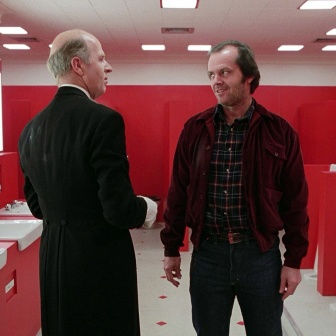Create a playful interaction based on this image. Human:  What do you think these men are plotting with such serious expressions?

GPT: Maybe they’re planning the ultimate office prank! The man in the black suit could be the mastermind, showing the man in the red jacket a detailed map of their colleague's cubicle. They’re discussing how to fill it with hundreds of balloons without getting caught. Their serious expressions are because they know this is a high-stakes operation and they cannot afford to leave any evidence behind. What happens next? Do they pull it off without a hitch or does something hilariously unexpected derail their plans? 